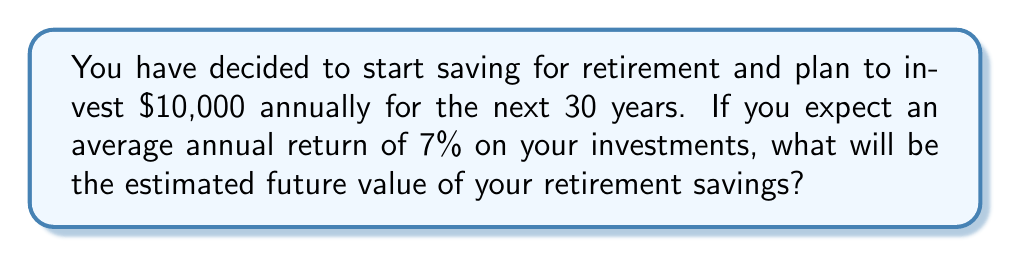Can you solve this math problem? To solve this problem, we'll use the formula for the future value of a series of equal payments with compound interest:

$$FV = P \cdot \frac{(1 + r)^n - 1}{r}$$

Where:
$FV$ = Future Value
$P$ = Annual Payment (Investment)
$r$ = Annual Interest Rate (as a decimal)
$n$ = Number of Years

Given:
$P = $10,000
$r = 0.07$ (7% expressed as a decimal)
$n = 30$ years

Let's substitute these values into the formula:

$$FV = 10000 \cdot \frac{(1 + 0.07)^{30} - 1}{0.07}$$

Now, let's calculate step by step:

1. Calculate $(1 + 0.07)^{30}$:
   $$(1.07)^{30} \approx 7.6123$$

2. Subtract 1:
   $$7.6123 - 1 = 6.6123$$

3. Divide by 0.07:
   $$\frac{6.6123}{0.07} \approx 94.4614$$

4. Multiply by $10,000:
   $$10000 \cdot 94.4614 = 944,614$$

Therefore, the estimated future value of your retirement savings after 30 years is approximately $944,614.
Answer: $944,614 